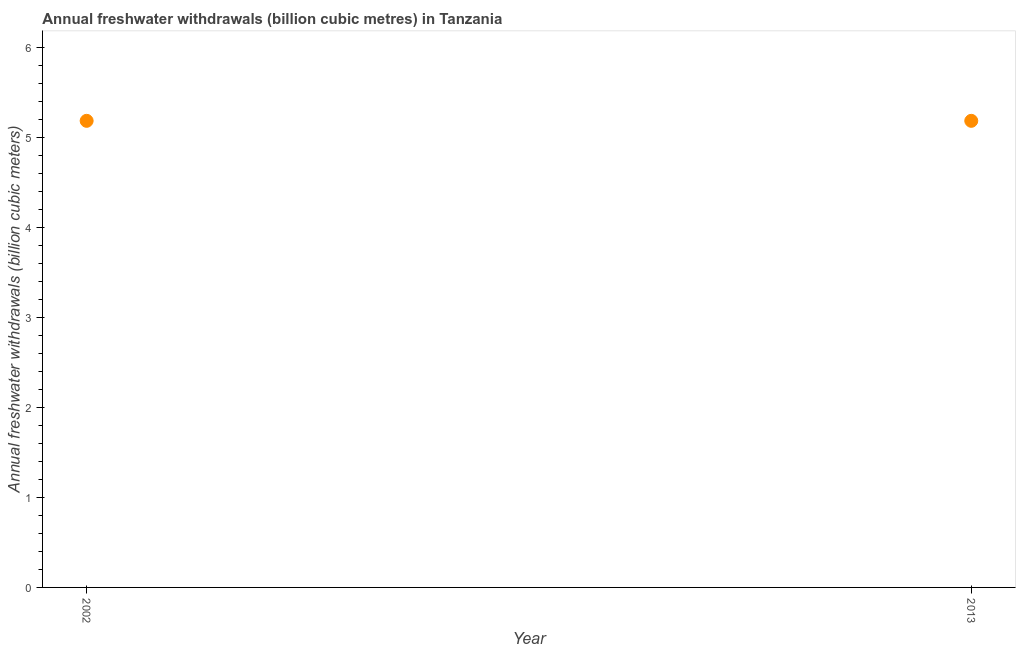What is the annual freshwater withdrawals in 2002?
Give a very brief answer. 5.18. Across all years, what is the maximum annual freshwater withdrawals?
Ensure brevity in your answer.  5.18. Across all years, what is the minimum annual freshwater withdrawals?
Keep it short and to the point. 5.18. What is the sum of the annual freshwater withdrawals?
Offer a very short reply. 10.37. What is the difference between the annual freshwater withdrawals in 2002 and 2013?
Provide a short and direct response. 0. What is the average annual freshwater withdrawals per year?
Your answer should be compact. 5.18. What is the median annual freshwater withdrawals?
Your response must be concise. 5.18. In how many years, is the annual freshwater withdrawals greater than 1.6 billion cubic meters?
Provide a short and direct response. 2. Do a majority of the years between 2013 and 2002 (inclusive) have annual freshwater withdrawals greater than 2 billion cubic meters?
Offer a terse response. No. What is the ratio of the annual freshwater withdrawals in 2002 to that in 2013?
Your answer should be very brief. 1. Is the annual freshwater withdrawals in 2002 less than that in 2013?
Offer a very short reply. No. What is the difference between two consecutive major ticks on the Y-axis?
Offer a very short reply. 1. Are the values on the major ticks of Y-axis written in scientific E-notation?
Offer a terse response. No. Does the graph contain grids?
Your response must be concise. No. What is the title of the graph?
Offer a terse response. Annual freshwater withdrawals (billion cubic metres) in Tanzania. What is the label or title of the Y-axis?
Give a very brief answer. Annual freshwater withdrawals (billion cubic meters). What is the Annual freshwater withdrawals (billion cubic meters) in 2002?
Provide a succinct answer. 5.18. What is the Annual freshwater withdrawals (billion cubic meters) in 2013?
Provide a short and direct response. 5.18. What is the ratio of the Annual freshwater withdrawals (billion cubic meters) in 2002 to that in 2013?
Provide a short and direct response. 1. 